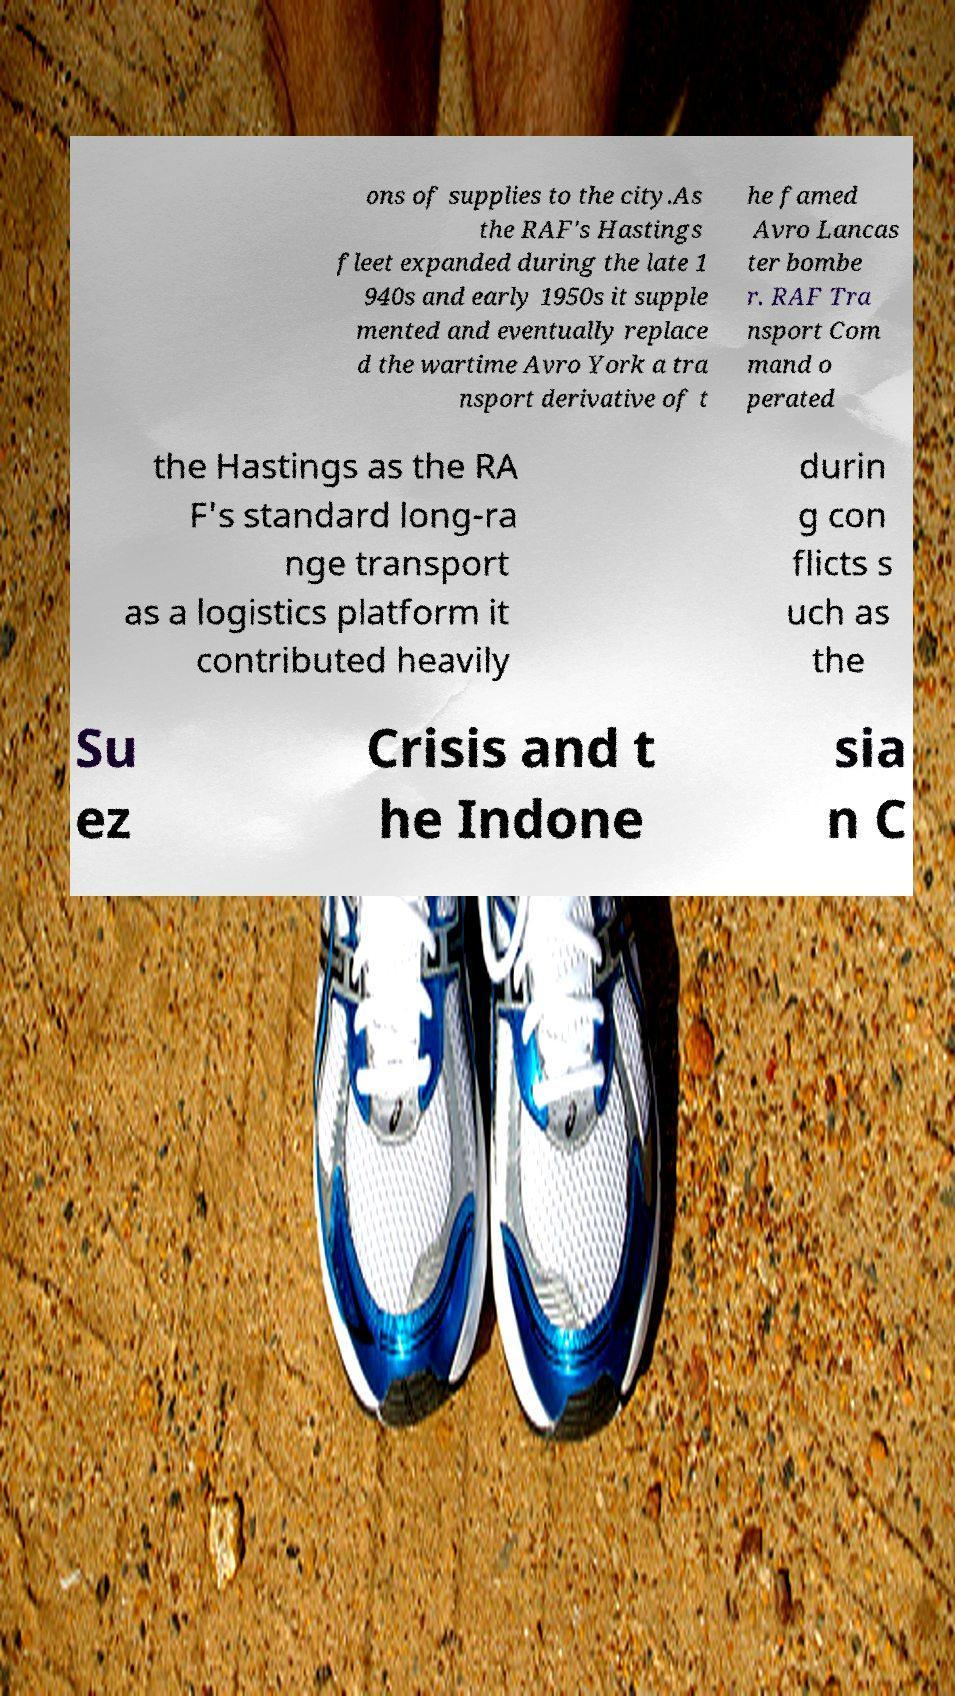What messages or text are displayed in this image? I need them in a readable, typed format. ons of supplies to the city.As the RAF's Hastings fleet expanded during the late 1 940s and early 1950s it supple mented and eventually replace d the wartime Avro York a tra nsport derivative of t he famed Avro Lancas ter bombe r. RAF Tra nsport Com mand o perated the Hastings as the RA F's standard long-ra nge transport as a logistics platform it contributed heavily durin g con flicts s uch as the Su ez Crisis and t he Indone sia n C 